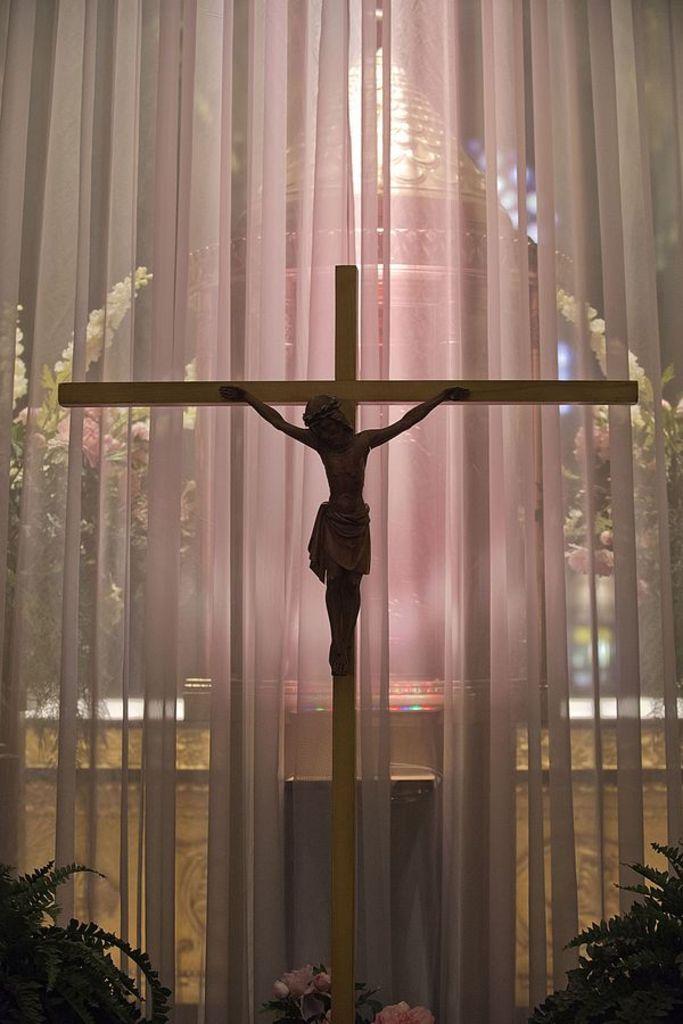Please provide a concise description of this image. In this image there is a cross made of wood, there is a man on the cross, there are plants towards the bottom of the image, there are flowers towards the bottom of the image, there is the wall, there are plants towards the left of the image, there are plants towards the right of the image, there is a curtain, there is an object behind the curtain. 